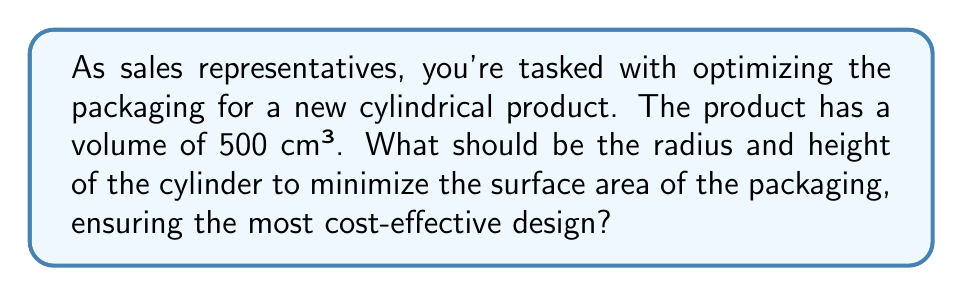Provide a solution to this math problem. Let's approach this step-by-step:

1) For a cylinder, we have:
   Volume: $V = \pi r^2 h$
   Surface Area: $A = 2\pi r^2 + 2\pi rh$

   Where $r$ is the radius and $h$ is the height.

2) We're given that $V = 500$ cm³. So:
   
   $500 = \pi r^2 h$

3) Solve for $h$:
   
   $h = \frac{500}{\pi r^2}$

4) Substitute this into the surface area formula:

   $A = 2\pi r^2 + 2\pi r(\frac{500}{\pi r^2})$

5) Simplify:

   $A = 2\pi r^2 + \frac{1000}{r}$

6) To find the minimum, we differentiate $A$ with respect to $r$ and set it to zero:

   $\frac{dA}{dr} = 4\pi r - \frac{1000}{r^2} = 0$

7) Solve this equation:

   $4\pi r^3 = 1000$
   $r^3 = \frac{250}{\pi}$
   $r = \sqrt[3]{\frac{250}{\pi}} \approx 4.24$ cm

8) Now we can find $h$:

   $h = \frac{500}{\pi r^2} = \frac{500}{\pi (\frac{250}{\pi})^{2/3}} = \sqrt[3]{\frac{250}{\pi}} \approx 4.24$ cm

9) Note that $r = h$, which is a property of the cylinder with minimum surface area for a given volume.
Answer: $r = h \approx 4.24$ cm 